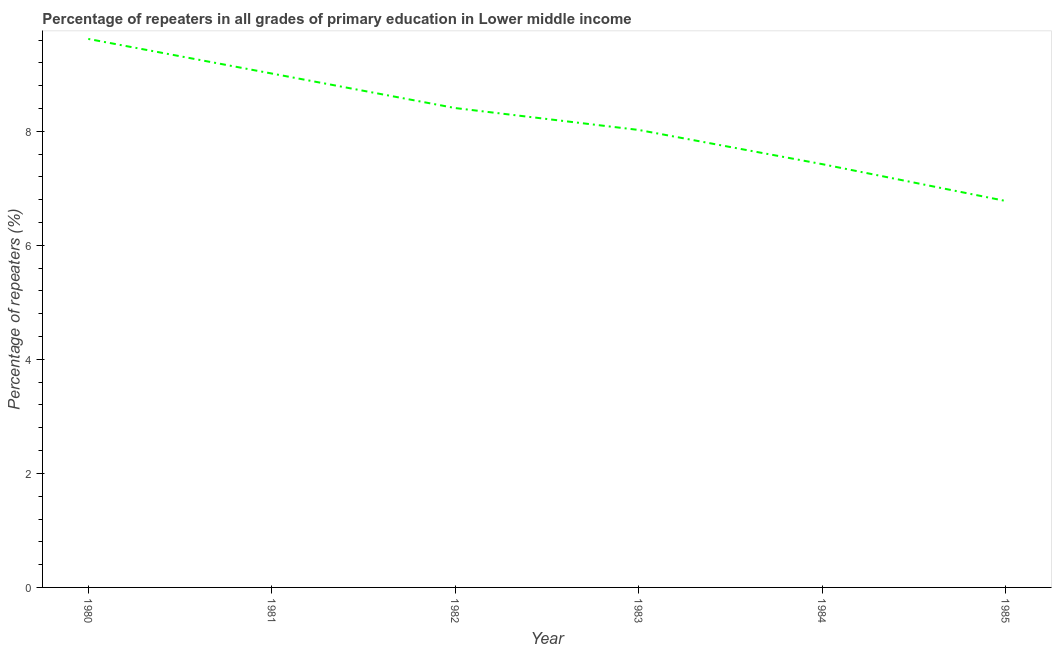What is the percentage of repeaters in primary education in 1982?
Provide a succinct answer. 8.41. Across all years, what is the maximum percentage of repeaters in primary education?
Your answer should be very brief. 9.62. Across all years, what is the minimum percentage of repeaters in primary education?
Make the answer very short. 6.78. In which year was the percentage of repeaters in primary education maximum?
Keep it short and to the point. 1980. In which year was the percentage of repeaters in primary education minimum?
Provide a succinct answer. 1985. What is the sum of the percentage of repeaters in primary education?
Offer a terse response. 49.27. What is the difference between the percentage of repeaters in primary education in 1980 and 1981?
Provide a succinct answer. 0.61. What is the average percentage of repeaters in primary education per year?
Your answer should be compact. 8.21. What is the median percentage of repeaters in primary education?
Provide a succinct answer. 8.22. What is the ratio of the percentage of repeaters in primary education in 1982 to that in 1984?
Ensure brevity in your answer.  1.13. Is the percentage of repeaters in primary education in 1982 less than that in 1985?
Ensure brevity in your answer.  No. What is the difference between the highest and the second highest percentage of repeaters in primary education?
Your answer should be compact. 0.61. Is the sum of the percentage of repeaters in primary education in 1984 and 1985 greater than the maximum percentage of repeaters in primary education across all years?
Your response must be concise. Yes. What is the difference between the highest and the lowest percentage of repeaters in primary education?
Your answer should be compact. 2.84. In how many years, is the percentage of repeaters in primary education greater than the average percentage of repeaters in primary education taken over all years?
Your response must be concise. 3. Does the percentage of repeaters in primary education monotonically increase over the years?
Provide a short and direct response. No. How many lines are there?
Keep it short and to the point. 1. How many years are there in the graph?
Offer a very short reply. 6. Are the values on the major ticks of Y-axis written in scientific E-notation?
Ensure brevity in your answer.  No. Does the graph contain any zero values?
Ensure brevity in your answer.  No. Does the graph contain grids?
Your answer should be compact. No. What is the title of the graph?
Give a very brief answer. Percentage of repeaters in all grades of primary education in Lower middle income. What is the label or title of the Y-axis?
Give a very brief answer. Percentage of repeaters (%). What is the Percentage of repeaters (%) in 1980?
Your answer should be very brief. 9.62. What is the Percentage of repeaters (%) of 1981?
Your response must be concise. 9.01. What is the Percentage of repeaters (%) of 1982?
Provide a short and direct response. 8.41. What is the Percentage of repeaters (%) of 1983?
Offer a very short reply. 8.02. What is the Percentage of repeaters (%) of 1984?
Your response must be concise. 7.42. What is the Percentage of repeaters (%) in 1985?
Keep it short and to the point. 6.78. What is the difference between the Percentage of repeaters (%) in 1980 and 1981?
Keep it short and to the point. 0.61. What is the difference between the Percentage of repeaters (%) in 1980 and 1982?
Offer a terse response. 1.21. What is the difference between the Percentage of repeaters (%) in 1980 and 1983?
Your answer should be compact. 1.6. What is the difference between the Percentage of repeaters (%) in 1980 and 1984?
Provide a short and direct response. 2.2. What is the difference between the Percentage of repeaters (%) in 1980 and 1985?
Keep it short and to the point. 2.84. What is the difference between the Percentage of repeaters (%) in 1981 and 1982?
Your answer should be very brief. 0.61. What is the difference between the Percentage of repeaters (%) in 1981 and 1983?
Give a very brief answer. 0.99. What is the difference between the Percentage of repeaters (%) in 1981 and 1984?
Offer a very short reply. 1.59. What is the difference between the Percentage of repeaters (%) in 1981 and 1985?
Ensure brevity in your answer.  2.24. What is the difference between the Percentage of repeaters (%) in 1982 and 1983?
Your answer should be very brief. 0.38. What is the difference between the Percentage of repeaters (%) in 1982 and 1984?
Give a very brief answer. 0.98. What is the difference between the Percentage of repeaters (%) in 1982 and 1985?
Offer a terse response. 1.63. What is the difference between the Percentage of repeaters (%) in 1983 and 1984?
Your answer should be compact. 0.6. What is the difference between the Percentage of repeaters (%) in 1983 and 1985?
Your response must be concise. 1.25. What is the difference between the Percentage of repeaters (%) in 1984 and 1985?
Your response must be concise. 0.65. What is the ratio of the Percentage of repeaters (%) in 1980 to that in 1981?
Provide a short and direct response. 1.07. What is the ratio of the Percentage of repeaters (%) in 1980 to that in 1982?
Offer a terse response. 1.14. What is the ratio of the Percentage of repeaters (%) in 1980 to that in 1983?
Your response must be concise. 1.2. What is the ratio of the Percentage of repeaters (%) in 1980 to that in 1984?
Offer a very short reply. 1.3. What is the ratio of the Percentage of repeaters (%) in 1980 to that in 1985?
Your response must be concise. 1.42. What is the ratio of the Percentage of repeaters (%) in 1981 to that in 1982?
Make the answer very short. 1.07. What is the ratio of the Percentage of repeaters (%) in 1981 to that in 1983?
Make the answer very short. 1.12. What is the ratio of the Percentage of repeaters (%) in 1981 to that in 1984?
Provide a short and direct response. 1.21. What is the ratio of the Percentage of repeaters (%) in 1981 to that in 1985?
Make the answer very short. 1.33. What is the ratio of the Percentage of repeaters (%) in 1982 to that in 1983?
Keep it short and to the point. 1.05. What is the ratio of the Percentage of repeaters (%) in 1982 to that in 1984?
Make the answer very short. 1.13. What is the ratio of the Percentage of repeaters (%) in 1982 to that in 1985?
Make the answer very short. 1.24. What is the ratio of the Percentage of repeaters (%) in 1983 to that in 1984?
Provide a succinct answer. 1.08. What is the ratio of the Percentage of repeaters (%) in 1983 to that in 1985?
Make the answer very short. 1.18. What is the ratio of the Percentage of repeaters (%) in 1984 to that in 1985?
Offer a very short reply. 1.09. 